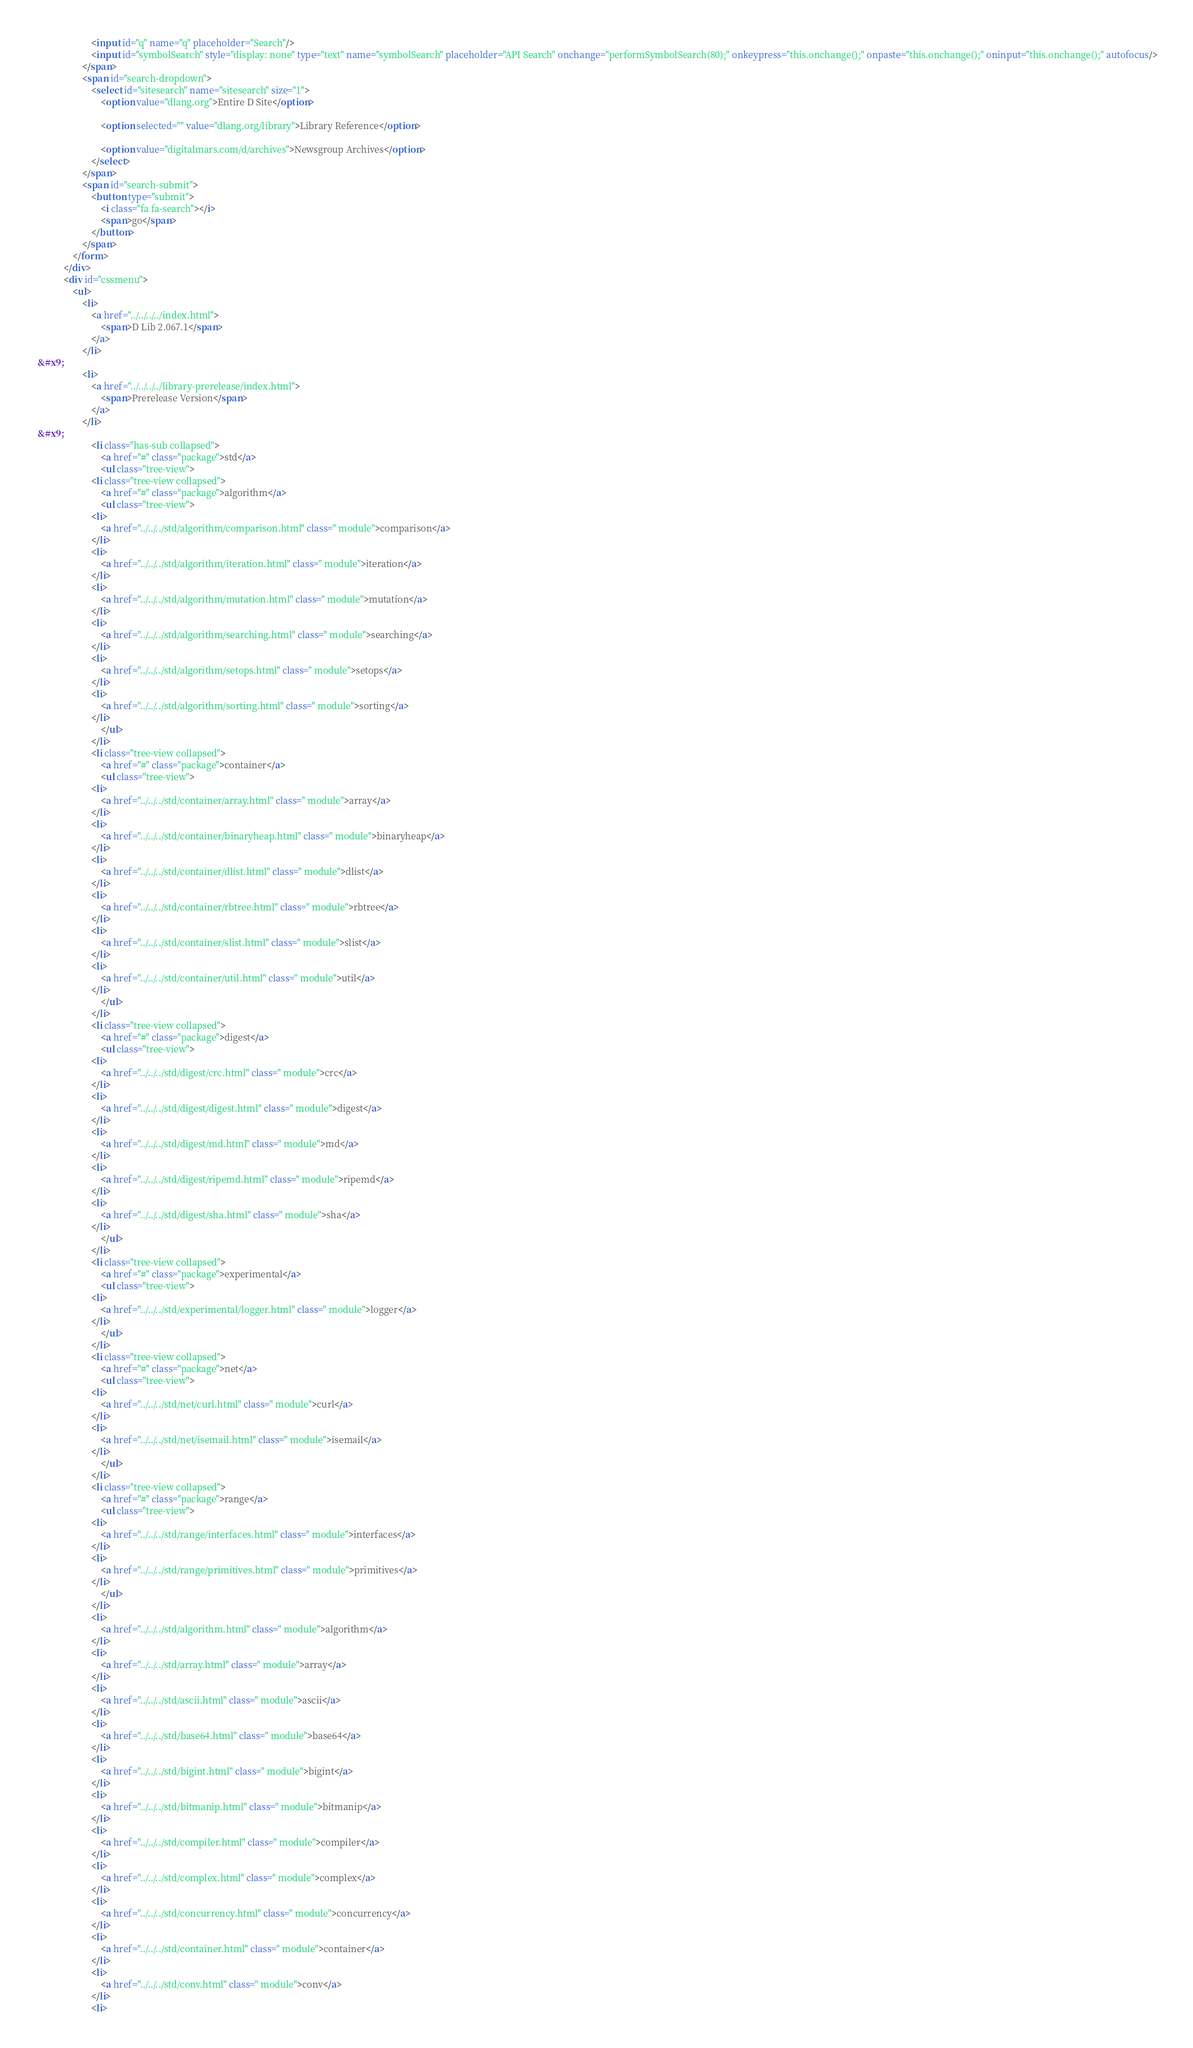Convert code to text. <code><loc_0><loc_0><loc_500><loc_500><_HTML_>						<input id="q" name="q" placeholder="Search"/>
						<input id="symbolSearch" style="display: none" type="text" name="symbolSearch" placeholder="API Search" onchange="performSymbolSearch(80);" onkeypress="this.onchange();" onpaste="this.onchange();" oninput="this.onchange();" autofocus/>
					</span>
					<span id="search-dropdown">
						<select id="sitesearch" name="sitesearch" size="1">
							<option value="dlang.org">Entire D Site</option>
                     
							<option selected="" value="dlang.org/library">Library Reference</option>
                     
							<option value="digitalmars.com/d/archives">Newsgroup Archives</option>
						</select>
					</span>
					<span id="search-submit">
						<button type="submit">
							<i class="fa fa-search"></i>
							<span>go</span>
						</button>
					</span>
				</form>
			</div>
			<div id="cssmenu">
				<ul>
					<li>
						<a href="../../../../index.html">
							<span>D Lib 2.067.1</span>
						</a>
					</li>
 &#x9;
					<li>
						<a href="../../../../library-prerelease/index.html">
							<span>Prerelease Version</span>
						</a>
					</li>
 &#x9;
						<li class="has-sub collapsed">
							<a href="#" class="package">std</a>
							<ul class="tree-view">
						<li class="tree-view collapsed">
							<a href="#" class="package">algorithm</a>
							<ul class="tree-view">
						<li>
							<a href="../../../std/algorithm/comparison.html" class=" module">comparison</a>
						</li>
						<li>
							<a href="../../../std/algorithm/iteration.html" class=" module">iteration</a>
						</li>
						<li>
							<a href="../../../std/algorithm/mutation.html" class=" module">mutation</a>
						</li>
						<li>
							<a href="../../../std/algorithm/searching.html" class=" module">searching</a>
						</li>
						<li>
							<a href="../../../std/algorithm/setops.html" class=" module">setops</a>
						</li>
						<li>
							<a href="../../../std/algorithm/sorting.html" class=" module">sorting</a>
						</li>
							</ul>
						</li>
						<li class="tree-view collapsed">
							<a href="#" class="package">container</a>
							<ul class="tree-view">
						<li>
							<a href="../../../std/container/array.html" class=" module">array</a>
						</li>
						<li>
							<a href="../../../std/container/binaryheap.html" class=" module">binaryheap</a>
						</li>
						<li>
							<a href="../../../std/container/dlist.html" class=" module">dlist</a>
						</li>
						<li>
							<a href="../../../std/container/rbtree.html" class=" module">rbtree</a>
						</li>
						<li>
							<a href="../../../std/container/slist.html" class=" module">slist</a>
						</li>
						<li>
							<a href="../../../std/container/util.html" class=" module">util</a>
						</li>
							</ul>
						</li>
						<li class="tree-view collapsed">
							<a href="#" class="package">digest</a>
							<ul class="tree-view">
						<li>
							<a href="../../../std/digest/crc.html" class=" module">crc</a>
						</li>
						<li>
							<a href="../../../std/digest/digest.html" class=" module">digest</a>
						</li>
						<li>
							<a href="../../../std/digest/md.html" class=" module">md</a>
						</li>
						<li>
							<a href="../../../std/digest/ripemd.html" class=" module">ripemd</a>
						</li>
						<li>
							<a href="../../../std/digest/sha.html" class=" module">sha</a>
						</li>
							</ul>
						</li>
						<li class="tree-view collapsed">
							<a href="#" class="package">experimental</a>
							<ul class="tree-view">
						<li>
							<a href="../../../std/experimental/logger.html" class=" module">logger</a>
						</li>
							</ul>
						</li>
						<li class="tree-view collapsed">
							<a href="#" class="package">net</a>
							<ul class="tree-view">
						<li>
							<a href="../../../std/net/curl.html" class=" module">curl</a>
						</li>
						<li>
							<a href="../../../std/net/isemail.html" class=" module">isemail</a>
						</li>
							</ul>
						</li>
						<li class="tree-view collapsed">
							<a href="#" class="package">range</a>
							<ul class="tree-view">
						<li>
							<a href="../../../std/range/interfaces.html" class=" module">interfaces</a>
						</li>
						<li>
							<a href="../../../std/range/primitives.html" class=" module">primitives</a>
						</li>
							</ul>
						</li>
						<li>
							<a href="../../../std/algorithm.html" class=" module">algorithm</a>
						</li>
						<li>
							<a href="../../../std/array.html" class=" module">array</a>
						</li>
						<li>
							<a href="../../../std/ascii.html" class=" module">ascii</a>
						</li>
						<li>
							<a href="../../../std/base64.html" class=" module">base64</a>
						</li>
						<li>
							<a href="../../../std/bigint.html" class=" module">bigint</a>
						</li>
						<li>
							<a href="../../../std/bitmanip.html" class=" module">bitmanip</a>
						</li>
						<li>
							<a href="../../../std/compiler.html" class=" module">compiler</a>
						</li>
						<li>
							<a href="../../../std/complex.html" class=" module">complex</a>
						</li>
						<li>
							<a href="../../../std/concurrency.html" class=" module">concurrency</a>
						</li>
						<li>
							<a href="../../../std/container.html" class=" module">container</a>
						</li>
						<li>
							<a href="../../../std/conv.html" class=" module">conv</a>
						</li>
						<li></code> 